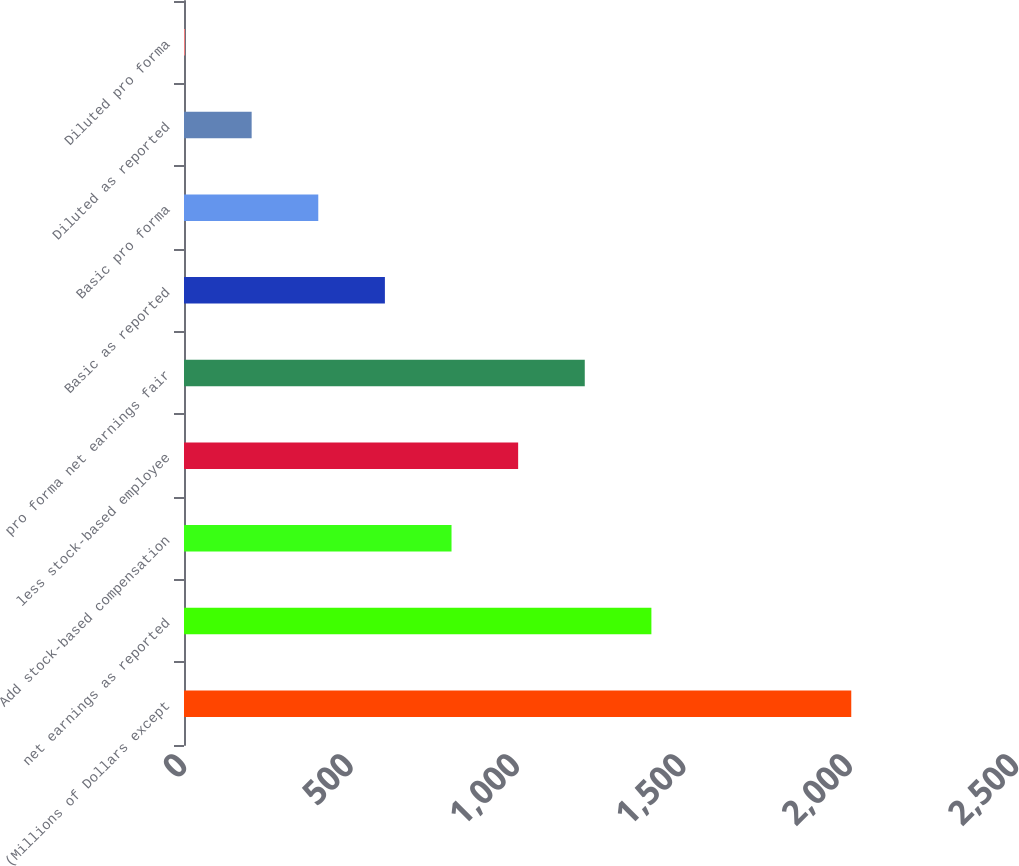Convert chart to OTSL. <chart><loc_0><loc_0><loc_500><loc_500><bar_chart><fcel>(Millions of Dollars except<fcel>net earnings as reported<fcel>Add stock-based compensation<fcel>less stock-based employee<fcel>pro forma net earnings fair<fcel>Basic as reported<fcel>Basic pro forma<fcel>Diluted as reported<fcel>Diluted pro forma<nl><fcel>2005<fcel>1404.42<fcel>803.85<fcel>1004.04<fcel>1204.23<fcel>603.66<fcel>403.47<fcel>203.28<fcel>3.09<nl></chart> 